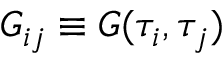Convert formula to latex. <formula><loc_0><loc_0><loc_500><loc_500>G _ { i j } \equiv G ( \tau _ { i } , \tau _ { j } )</formula> 